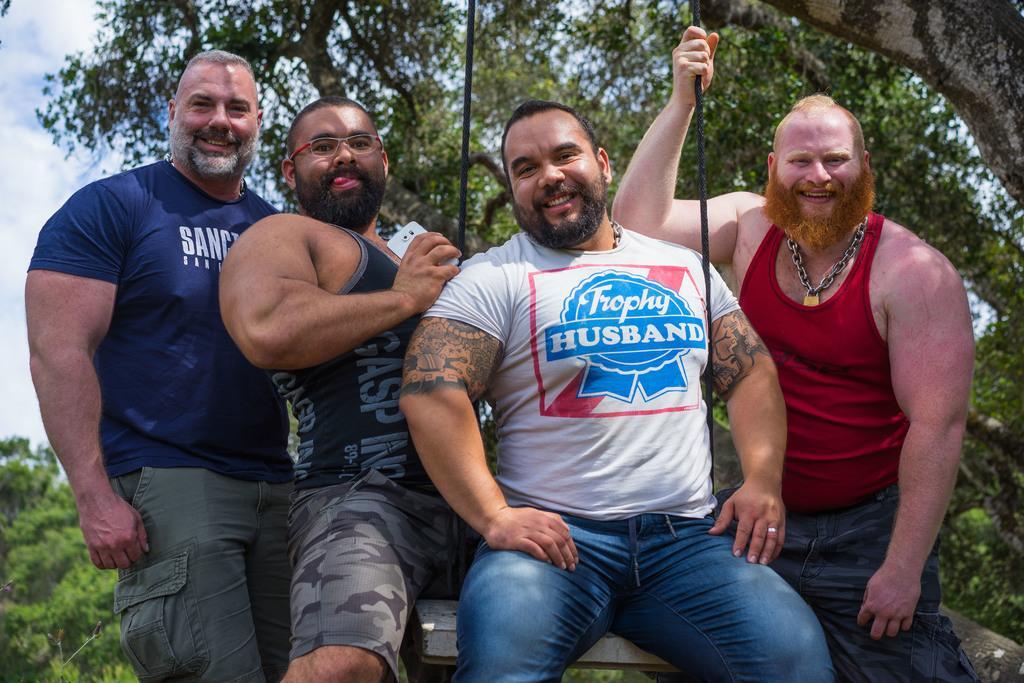Can you describe this image briefly? There are four persons where one among them is sitting on a cradle which is tightened to a tree and the remaining are standing beside him. 